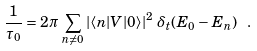<formula> <loc_0><loc_0><loc_500><loc_500>\frac { 1 } { \tau _ { 0 } } = 2 \pi \, \sum _ { n \neq 0 } \left | \langle n | V | 0 \rangle \right | ^ { 2 } \, \delta _ { t } ( E _ { 0 } - E _ { n } ) \ .</formula> 